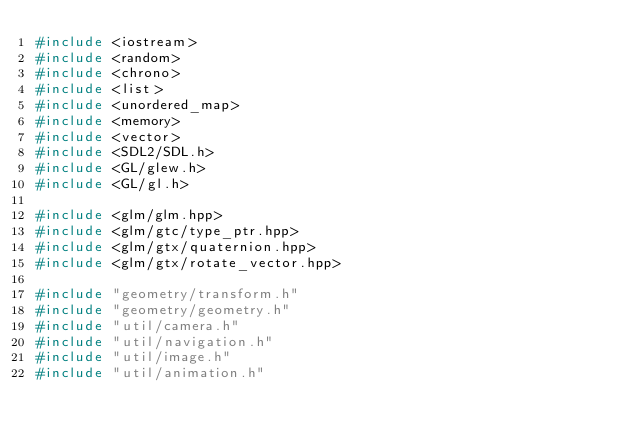Convert code to text. <code><loc_0><loc_0><loc_500><loc_500><_C++_>#include <iostream>
#include <random>
#include <chrono>
#include <list>
#include <unordered_map>
#include <memory>
#include <vector>
#include <SDL2/SDL.h>
#include <GL/glew.h>
#include <GL/gl.h>

#include <glm/glm.hpp>
#include <glm/gtc/type_ptr.hpp>
#include <glm/gtx/quaternion.hpp>
#include <glm/gtx/rotate_vector.hpp>

#include "geometry/transform.h"
#include "geometry/geometry.h"
#include "util/camera.h"
#include "util/navigation.h"
#include "util/image.h"
#include "util/animation.h"</code> 